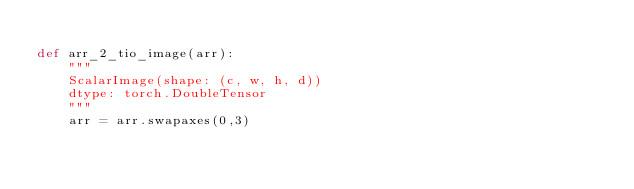Convert code to text. <code><loc_0><loc_0><loc_500><loc_500><_Python_>
def arr_2_tio_image(arr):
    """
    ScalarImage(shape: (c, w, h, d))
    dtype: torch.DoubleTensor
    """
    arr = arr.swapaxes(0,3)</code> 